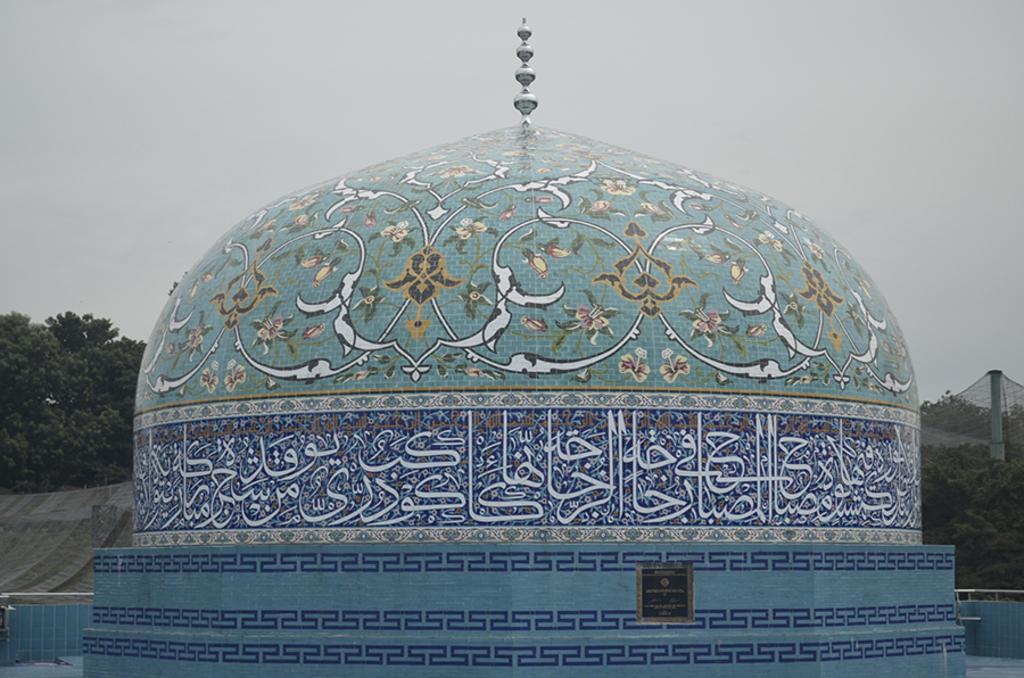Could you give a brief overview of what you see in this image? In this image I can see the dome and the dome is in blue, green and white color. Background I can see few trees in green color and the sky is in white color. 